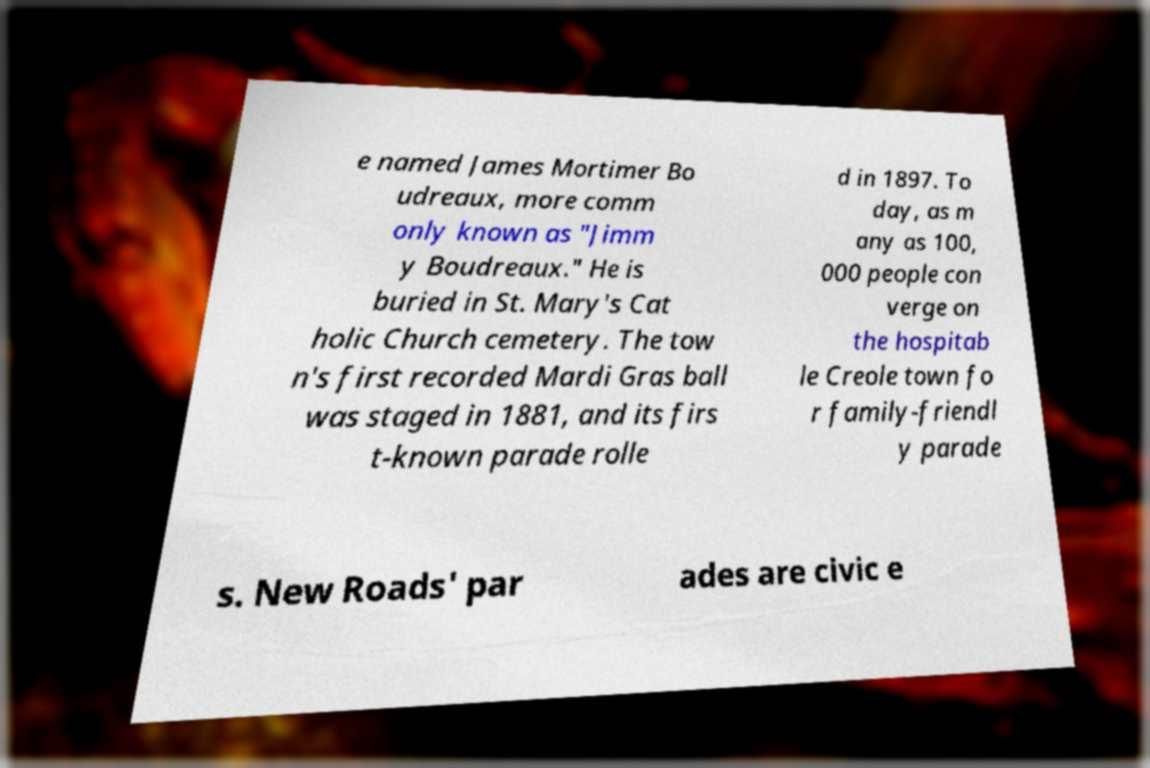Can you accurately transcribe the text from the provided image for me? e named James Mortimer Bo udreaux, more comm only known as "Jimm y Boudreaux." He is buried in St. Mary's Cat holic Church cemetery. The tow n's first recorded Mardi Gras ball was staged in 1881, and its firs t-known parade rolle d in 1897. To day, as m any as 100, 000 people con verge on the hospitab le Creole town fo r family-friendl y parade s. New Roads' par ades are civic e 